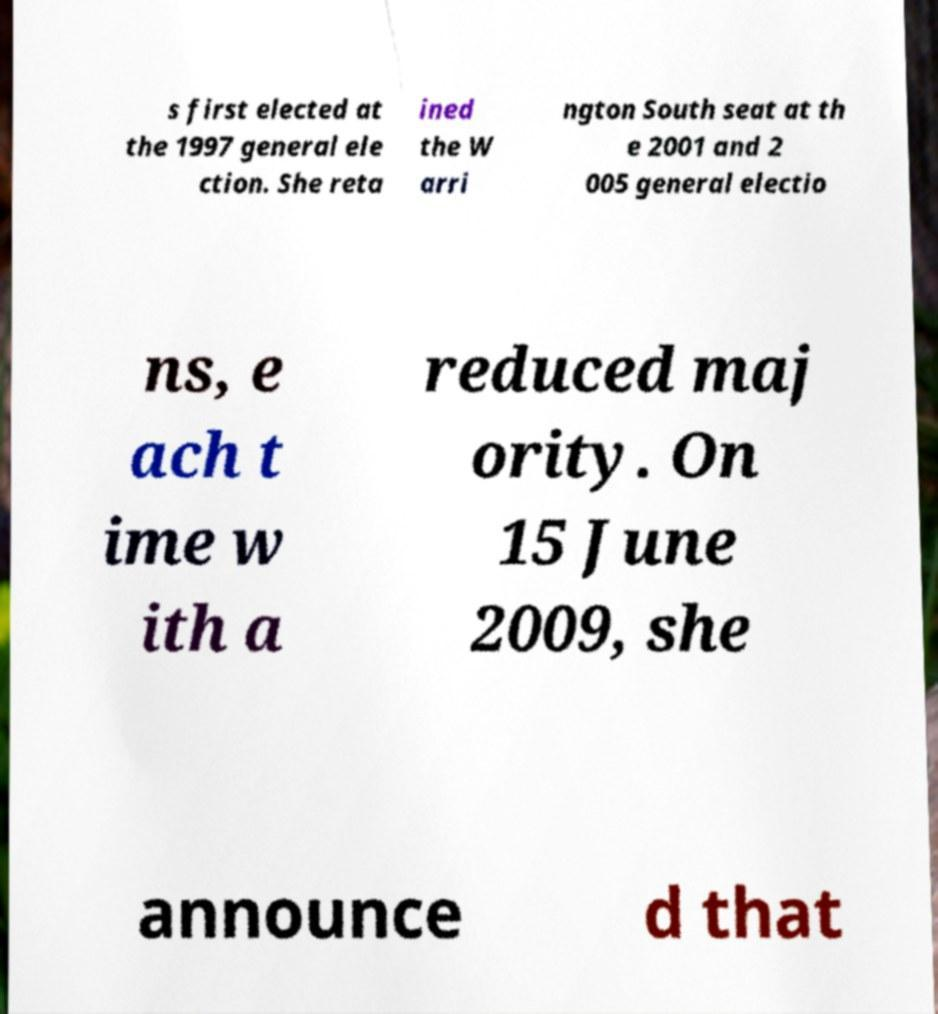Can you read and provide the text displayed in the image?This photo seems to have some interesting text. Can you extract and type it out for me? s first elected at the 1997 general ele ction. She reta ined the W arri ngton South seat at th e 2001 and 2 005 general electio ns, e ach t ime w ith a reduced maj ority. On 15 June 2009, she announce d that 